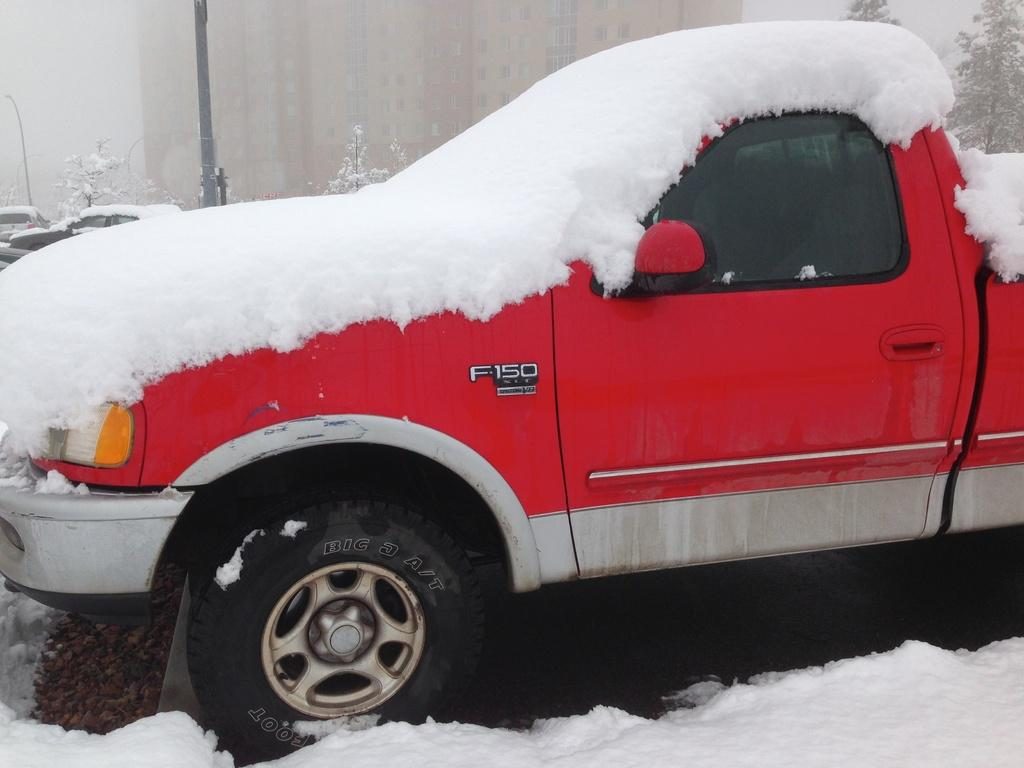<image>
Write a terse but informative summary of the picture. A red pick-up truck is marked as an F-150. 